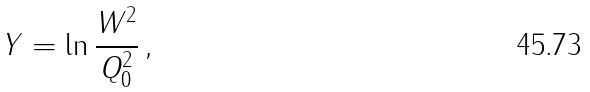Convert formula to latex. <formula><loc_0><loc_0><loc_500><loc_500>Y = \ln \frac { W ^ { 2 } } { Q _ { 0 } ^ { 2 } } \, ,</formula> 